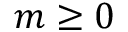Convert formula to latex. <formula><loc_0><loc_0><loc_500><loc_500>m \geq 0</formula> 